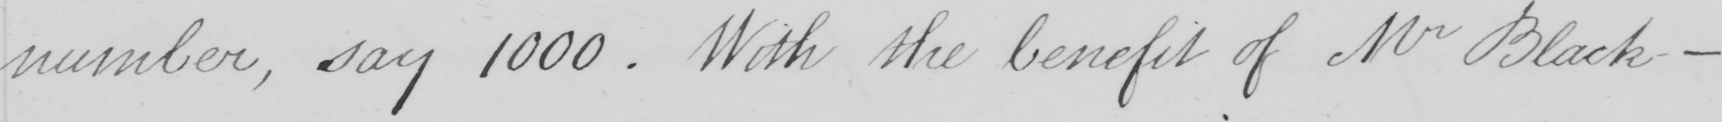Can you read and transcribe this handwriting? number , say 1000 . With the benefit of Mr Black- 